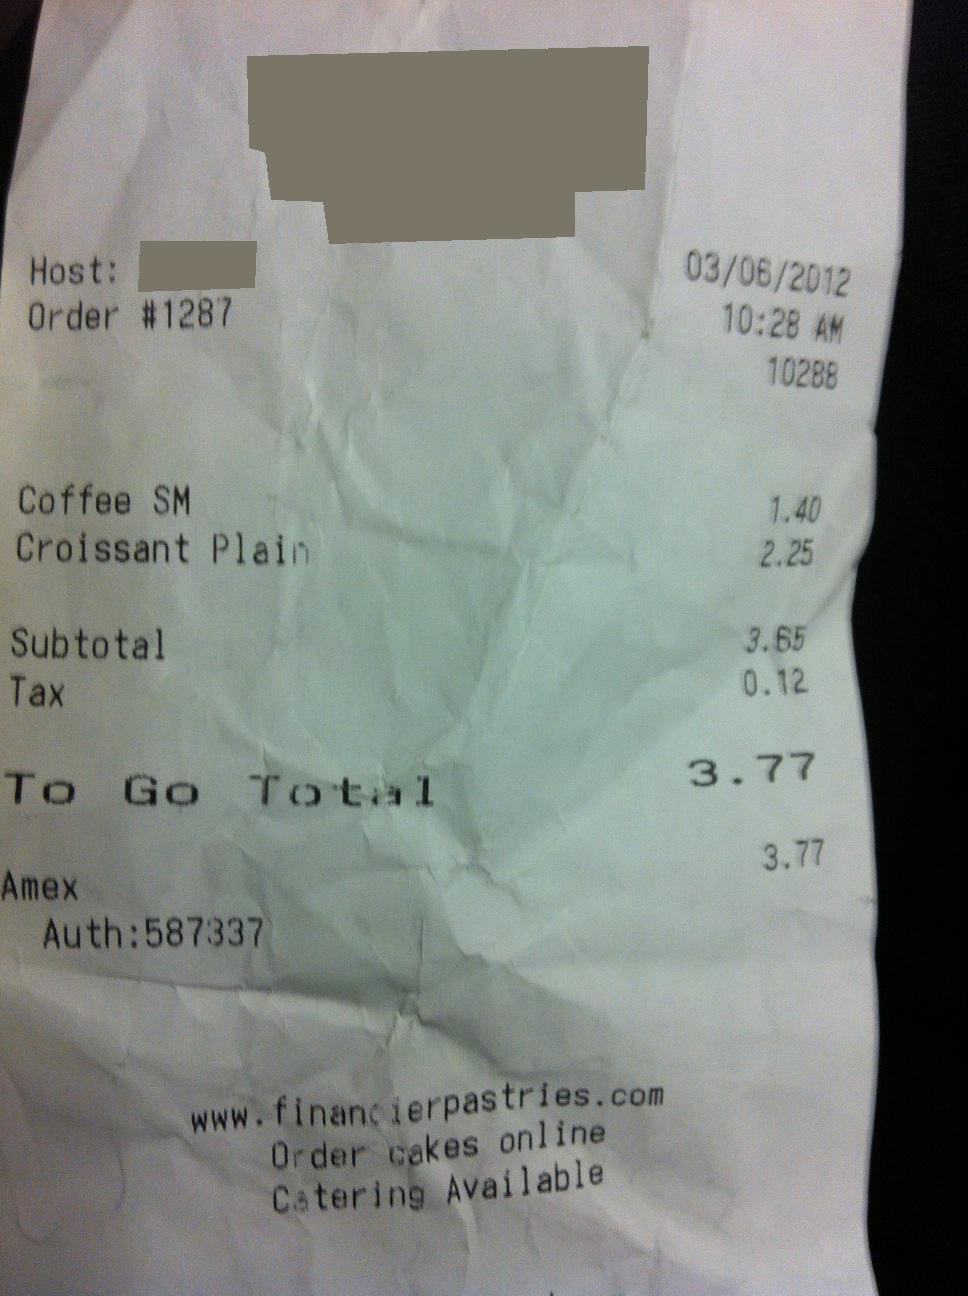Did the person pay for the items to go or was it for dine-in? Based on the receipt, it seems that the items were purchased 'To Go', as indicated by the 'To Go Total' line. 